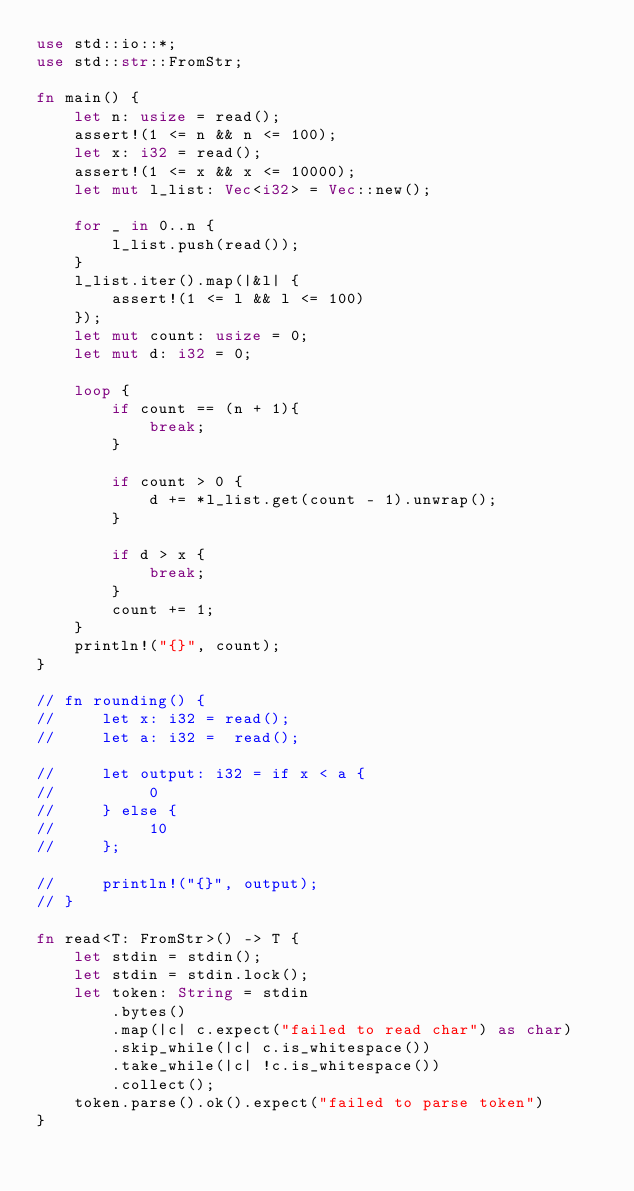Convert code to text. <code><loc_0><loc_0><loc_500><loc_500><_Rust_>use std::io::*;
use std::str::FromStr;

fn main() {
    let n: usize = read();
    assert!(1 <= n && n <= 100);
    let x: i32 = read();
    assert!(1 <= x && x <= 10000);
    let mut l_list: Vec<i32> = Vec::new();

    for _ in 0..n {
        l_list.push(read());
    }
    l_list.iter().map(|&l| {
        assert!(1 <= l && l <= 100)
    });
    let mut count: usize = 0;
    let mut d: i32 = 0;

    loop {
        if count == (n + 1){
            break;
        }

        if count > 0 {
            d += *l_list.get(count - 1).unwrap();
        }

        if d > x {
            break;
        }
        count += 1;
    }
    println!("{}", count);
}

// fn rounding() {
//     let x: i32 = read();
//     let a: i32 =  read();
    
//     let output: i32 = if x < a {
//          0
//     } else {
//          10
//     };

//     println!("{}", output);
// }

fn read<T: FromStr>() -> T {
    let stdin = stdin();
    let stdin = stdin.lock();
    let token: String = stdin
        .bytes()
        .map(|c| c.expect("failed to read char") as char)
        .skip_while(|c| c.is_whitespace())
        .take_while(|c| !c.is_whitespace())
        .collect();
    token.parse().ok().expect("failed to parse token")
}
</code> 